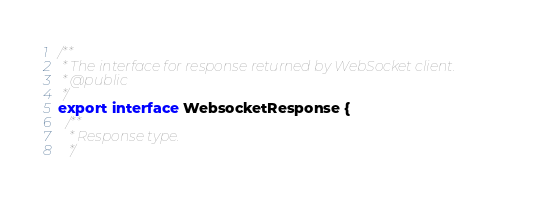Convert code to text. <code><loc_0><loc_0><loc_500><loc_500><_TypeScript_>/**
 * The interface for response returned by WebSocket client.
 * @public
 */
export interface WebsocketResponse {
  /**
   * Response type.
   */</code> 